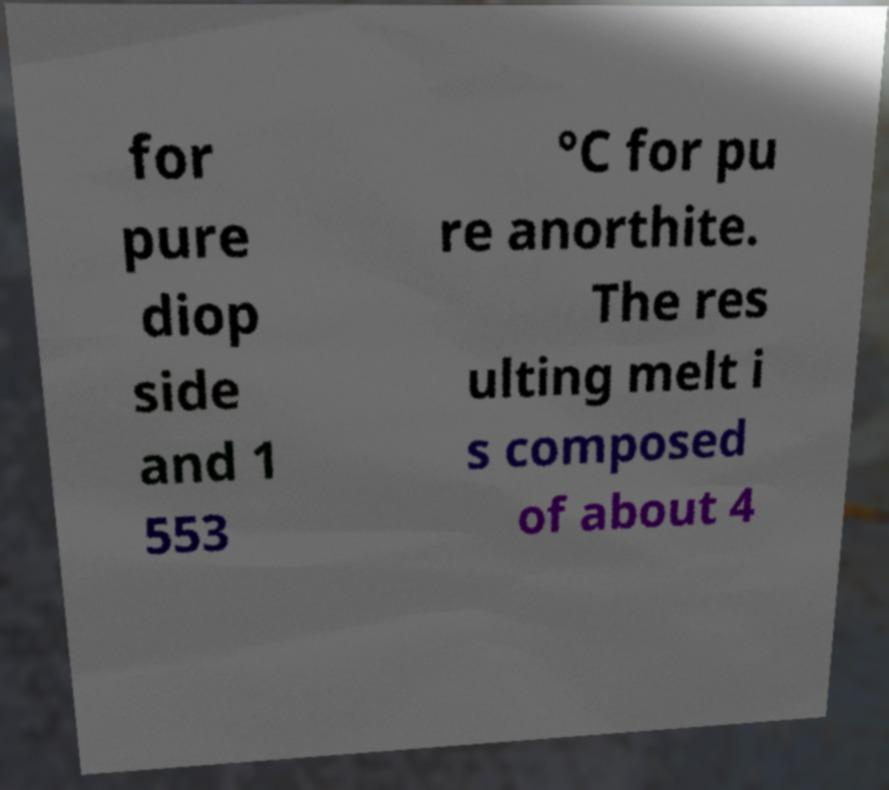Please read and relay the text visible in this image. What does it say? for pure diop side and 1 553 °C for pu re anorthite. The res ulting melt i s composed of about 4 